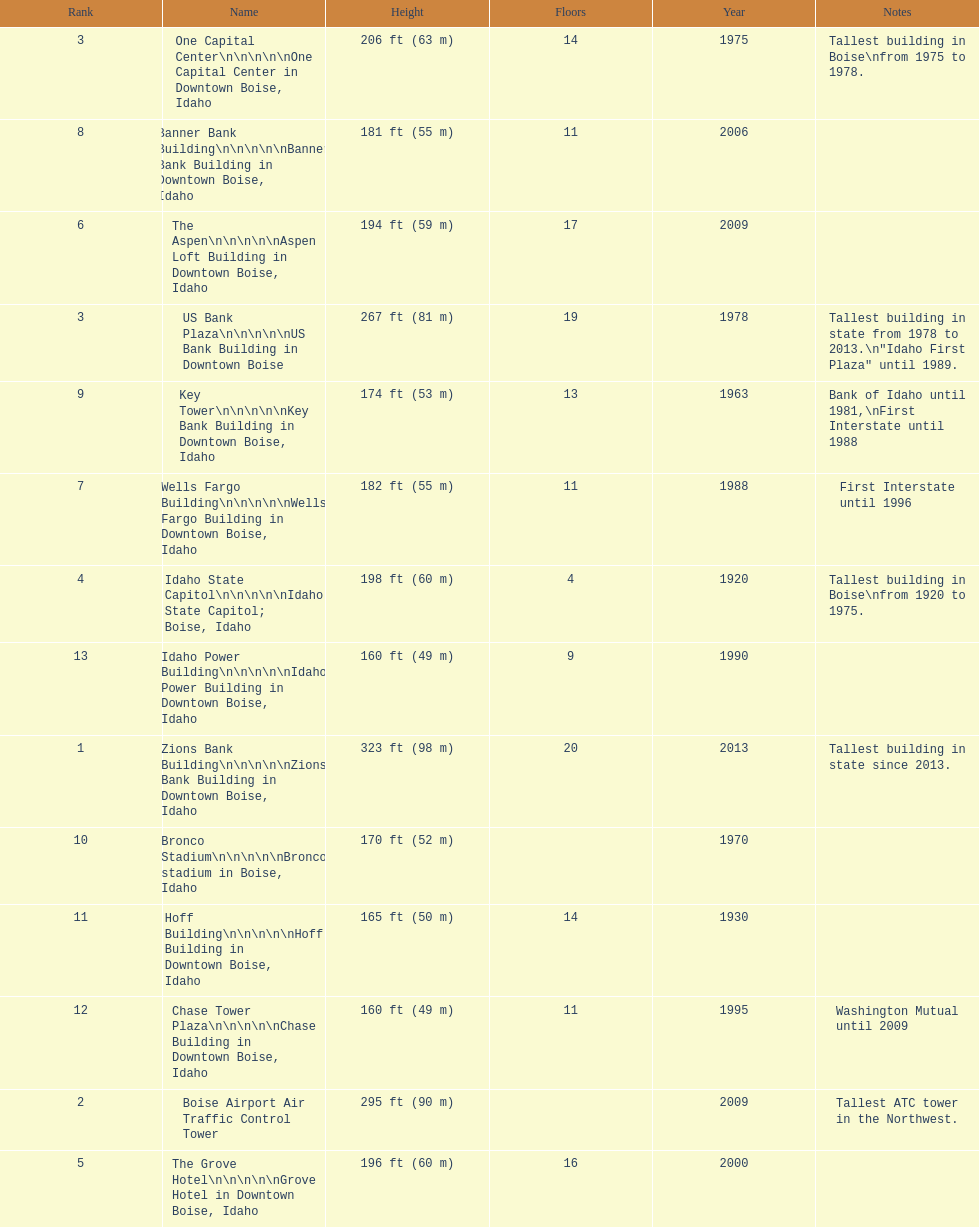Which building has the most floors according to this chart? Zions Bank Building. 